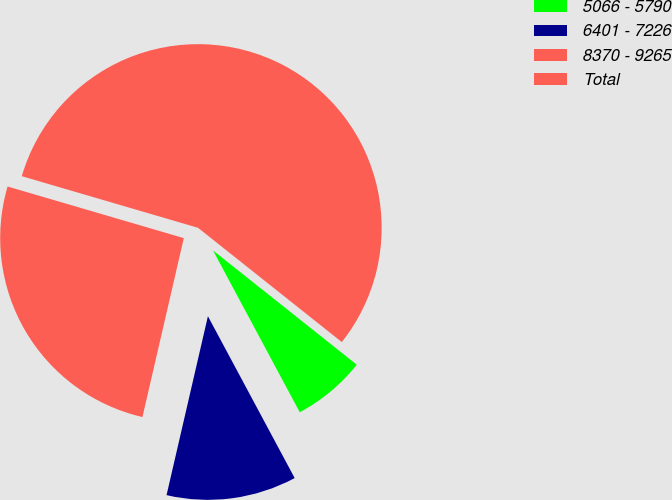Convert chart to OTSL. <chart><loc_0><loc_0><loc_500><loc_500><pie_chart><fcel>5066 - 5790<fcel>6401 - 7226<fcel>8370 - 9265<fcel>Total<nl><fcel>6.48%<fcel>11.45%<fcel>25.92%<fcel>56.16%<nl></chart> 